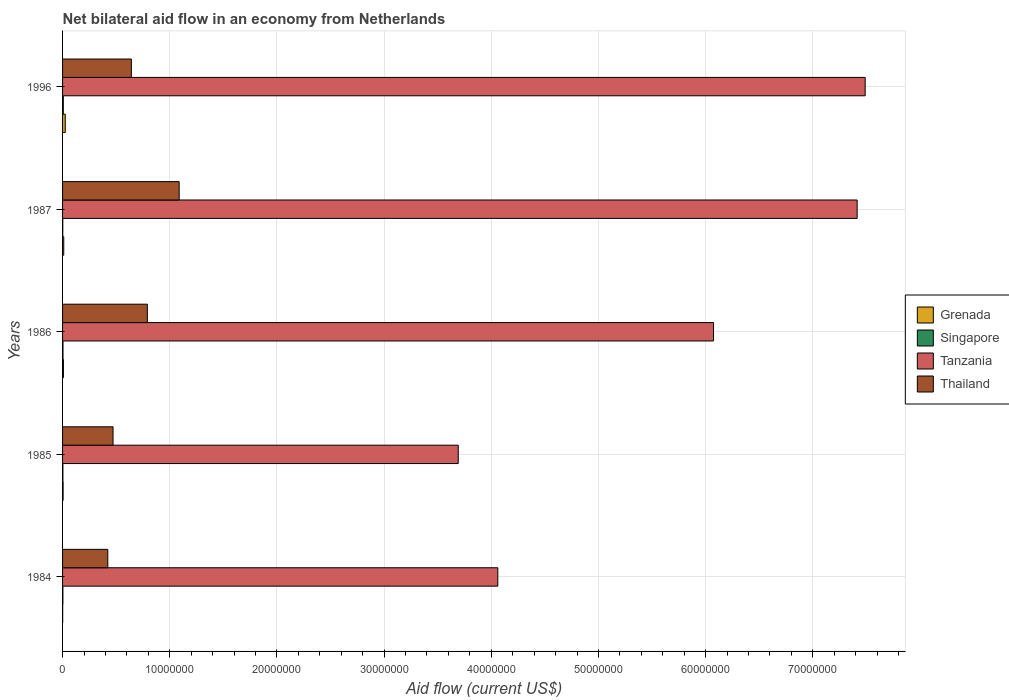How many bars are there on the 1st tick from the bottom?
Ensure brevity in your answer.  4. In how many cases, is the number of bars for a given year not equal to the number of legend labels?
Keep it short and to the point. 0. What is the net bilateral aid flow in Thailand in 1987?
Your answer should be very brief. 1.09e+07. Across all years, what is the maximum net bilateral aid flow in Singapore?
Your answer should be compact. 7.00e+04. Across all years, what is the minimum net bilateral aid flow in Thailand?
Ensure brevity in your answer.  4.22e+06. In which year was the net bilateral aid flow in Singapore maximum?
Your answer should be compact. 1996. What is the total net bilateral aid flow in Grenada in the graph?
Keep it short and to the point. 5.00e+05. What is the difference between the net bilateral aid flow in Tanzania in 1986 and that in 1996?
Give a very brief answer. -1.42e+07. What is the difference between the net bilateral aid flow in Singapore in 1996 and the net bilateral aid flow in Thailand in 1986?
Your response must be concise. -7.84e+06. What is the average net bilateral aid flow in Singapore per year?
Your answer should be compact. 3.80e+04. In the year 1984, what is the difference between the net bilateral aid flow in Singapore and net bilateral aid flow in Tanzania?
Give a very brief answer. -4.06e+07. What is the ratio of the net bilateral aid flow in Grenada in 1985 to that in 1987?
Offer a terse response. 0.45. What is the difference between the highest and the lowest net bilateral aid flow in Grenada?
Offer a terse response. 2.40e+05. Is the sum of the net bilateral aid flow in Singapore in 1984 and 1987 greater than the maximum net bilateral aid flow in Thailand across all years?
Your answer should be compact. No. Is it the case that in every year, the sum of the net bilateral aid flow in Tanzania and net bilateral aid flow in Thailand is greater than the sum of net bilateral aid flow in Singapore and net bilateral aid flow in Grenada?
Provide a succinct answer. No. What does the 3rd bar from the top in 1985 represents?
Your answer should be compact. Singapore. What does the 2nd bar from the bottom in 1984 represents?
Offer a terse response. Singapore. How many bars are there?
Keep it short and to the point. 20. Are all the bars in the graph horizontal?
Offer a very short reply. Yes. How many years are there in the graph?
Keep it short and to the point. 5. Are the values on the major ticks of X-axis written in scientific E-notation?
Give a very brief answer. No. How many legend labels are there?
Offer a very short reply. 4. How are the legend labels stacked?
Ensure brevity in your answer.  Vertical. What is the title of the graph?
Ensure brevity in your answer.  Net bilateral aid flow in an economy from Netherlands. Does "High income" appear as one of the legend labels in the graph?
Offer a terse response. No. What is the Aid flow (current US$) of Singapore in 1984?
Make the answer very short. 3.00e+04. What is the Aid flow (current US$) of Tanzania in 1984?
Ensure brevity in your answer.  4.06e+07. What is the Aid flow (current US$) in Thailand in 1984?
Your answer should be very brief. 4.22e+06. What is the Aid flow (current US$) of Grenada in 1985?
Ensure brevity in your answer.  5.00e+04. What is the Aid flow (current US$) of Singapore in 1985?
Ensure brevity in your answer.  3.00e+04. What is the Aid flow (current US$) in Tanzania in 1985?
Your response must be concise. 3.69e+07. What is the Aid flow (current US$) in Thailand in 1985?
Provide a short and direct response. 4.71e+06. What is the Aid flow (current US$) of Singapore in 1986?
Provide a short and direct response. 4.00e+04. What is the Aid flow (current US$) of Tanzania in 1986?
Make the answer very short. 6.07e+07. What is the Aid flow (current US$) of Thailand in 1986?
Provide a short and direct response. 7.91e+06. What is the Aid flow (current US$) in Tanzania in 1987?
Give a very brief answer. 7.41e+07. What is the Aid flow (current US$) of Thailand in 1987?
Provide a short and direct response. 1.09e+07. What is the Aid flow (current US$) in Grenada in 1996?
Your response must be concise. 2.50e+05. What is the Aid flow (current US$) of Tanzania in 1996?
Your answer should be very brief. 7.49e+07. What is the Aid flow (current US$) in Thailand in 1996?
Your response must be concise. 6.42e+06. Across all years, what is the maximum Aid flow (current US$) of Singapore?
Give a very brief answer. 7.00e+04. Across all years, what is the maximum Aid flow (current US$) of Tanzania?
Offer a terse response. 7.49e+07. Across all years, what is the maximum Aid flow (current US$) in Thailand?
Offer a very short reply. 1.09e+07. Across all years, what is the minimum Aid flow (current US$) in Tanzania?
Make the answer very short. 3.69e+07. Across all years, what is the minimum Aid flow (current US$) in Thailand?
Ensure brevity in your answer.  4.22e+06. What is the total Aid flow (current US$) of Singapore in the graph?
Provide a succinct answer. 1.90e+05. What is the total Aid flow (current US$) of Tanzania in the graph?
Provide a succinct answer. 2.87e+08. What is the total Aid flow (current US$) in Thailand in the graph?
Provide a short and direct response. 3.41e+07. What is the difference between the Aid flow (current US$) of Grenada in 1984 and that in 1985?
Keep it short and to the point. -4.00e+04. What is the difference between the Aid flow (current US$) in Singapore in 1984 and that in 1985?
Keep it short and to the point. 0. What is the difference between the Aid flow (current US$) of Tanzania in 1984 and that in 1985?
Offer a very short reply. 3.69e+06. What is the difference between the Aid flow (current US$) in Thailand in 1984 and that in 1985?
Provide a short and direct response. -4.90e+05. What is the difference between the Aid flow (current US$) in Grenada in 1984 and that in 1986?
Your answer should be very brief. -7.00e+04. What is the difference between the Aid flow (current US$) of Singapore in 1984 and that in 1986?
Your answer should be compact. -10000. What is the difference between the Aid flow (current US$) in Tanzania in 1984 and that in 1986?
Ensure brevity in your answer.  -2.01e+07. What is the difference between the Aid flow (current US$) of Thailand in 1984 and that in 1986?
Keep it short and to the point. -3.69e+06. What is the difference between the Aid flow (current US$) of Grenada in 1984 and that in 1987?
Provide a succinct answer. -1.00e+05. What is the difference between the Aid flow (current US$) of Tanzania in 1984 and that in 1987?
Keep it short and to the point. -3.35e+07. What is the difference between the Aid flow (current US$) in Thailand in 1984 and that in 1987?
Your response must be concise. -6.66e+06. What is the difference between the Aid flow (current US$) of Tanzania in 1984 and that in 1996?
Give a very brief answer. -3.43e+07. What is the difference between the Aid flow (current US$) of Thailand in 1984 and that in 1996?
Keep it short and to the point. -2.20e+06. What is the difference between the Aid flow (current US$) of Singapore in 1985 and that in 1986?
Offer a very short reply. -10000. What is the difference between the Aid flow (current US$) in Tanzania in 1985 and that in 1986?
Provide a short and direct response. -2.38e+07. What is the difference between the Aid flow (current US$) in Thailand in 1985 and that in 1986?
Provide a succinct answer. -3.20e+06. What is the difference between the Aid flow (current US$) of Grenada in 1985 and that in 1987?
Your answer should be compact. -6.00e+04. What is the difference between the Aid flow (current US$) in Singapore in 1985 and that in 1987?
Your response must be concise. 10000. What is the difference between the Aid flow (current US$) of Tanzania in 1985 and that in 1987?
Your response must be concise. -3.72e+07. What is the difference between the Aid flow (current US$) in Thailand in 1985 and that in 1987?
Your response must be concise. -6.17e+06. What is the difference between the Aid flow (current US$) in Grenada in 1985 and that in 1996?
Provide a succinct answer. -2.00e+05. What is the difference between the Aid flow (current US$) of Singapore in 1985 and that in 1996?
Provide a short and direct response. -4.00e+04. What is the difference between the Aid flow (current US$) in Tanzania in 1985 and that in 1996?
Ensure brevity in your answer.  -3.80e+07. What is the difference between the Aid flow (current US$) in Thailand in 1985 and that in 1996?
Offer a terse response. -1.71e+06. What is the difference between the Aid flow (current US$) of Grenada in 1986 and that in 1987?
Offer a very short reply. -3.00e+04. What is the difference between the Aid flow (current US$) in Tanzania in 1986 and that in 1987?
Your answer should be very brief. -1.34e+07. What is the difference between the Aid flow (current US$) in Thailand in 1986 and that in 1987?
Provide a succinct answer. -2.97e+06. What is the difference between the Aid flow (current US$) in Tanzania in 1986 and that in 1996?
Your response must be concise. -1.42e+07. What is the difference between the Aid flow (current US$) in Thailand in 1986 and that in 1996?
Give a very brief answer. 1.49e+06. What is the difference between the Aid flow (current US$) of Tanzania in 1987 and that in 1996?
Your answer should be very brief. -7.50e+05. What is the difference between the Aid flow (current US$) in Thailand in 1987 and that in 1996?
Give a very brief answer. 4.46e+06. What is the difference between the Aid flow (current US$) of Grenada in 1984 and the Aid flow (current US$) of Tanzania in 1985?
Give a very brief answer. -3.69e+07. What is the difference between the Aid flow (current US$) of Grenada in 1984 and the Aid flow (current US$) of Thailand in 1985?
Your answer should be compact. -4.70e+06. What is the difference between the Aid flow (current US$) in Singapore in 1984 and the Aid flow (current US$) in Tanzania in 1985?
Provide a short and direct response. -3.69e+07. What is the difference between the Aid flow (current US$) of Singapore in 1984 and the Aid flow (current US$) of Thailand in 1985?
Ensure brevity in your answer.  -4.68e+06. What is the difference between the Aid flow (current US$) of Tanzania in 1984 and the Aid flow (current US$) of Thailand in 1985?
Provide a short and direct response. 3.59e+07. What is the difference between the Aid flow (current US$) of Grenada in 1984 and the Aid flow (current US$) of Tanzania in 1986?
Provide a short and direct response. -6.07e+07. What is the difference between the Aid flow (current US$) in Grenada in 1984 and the Aid flow (current US$) in Thailand in 1986?
Give a very brief answer. -7.90e+06. What is the difference between the Aid flow (current US$) of Singapore in 1984 and the Aid flow (current US$) of Tanzania in 1986?
Provide a succinct answer. -6.07e+07. What is the difference between the Aid flow (current US$) in Singapore in 1984 and the Aid flow (current US$) in Thailand in 1986?
Give a very brief answer. -7.88e+06. What is the difference between the Aid flow (current US$) in Tanzania in 1984 and the Aid flow (current US$) in Thailand in 1986?
Ensure brevity in your answer.  3.27e+07. What is the difference between the Aid flow (current US$) in Grenada in 1984 and the Aid flow (current US$) in Singapore in 1987?
Give a very brief answer. -10000. What is the difference between the Aid flow (current US$) of Grenada in 1984 and the Aid flow (current US$) of Tanzania in 1987?
Offer a terse response. -7.41e+07. What is the difference between the Aid flow (current US$) in Grenada in 1984 and the Aid flow (current US$) in Thailand in 1987?
Give a very brief answer. -1.09e+07. What is the difference between the Aid flow (current US$) of Singapore in 1984 and the Aid flow (current US$) of Tanzania in 1987?
Offer a very short reply. -7.41e+07. What is the difference between the Aid flow (current US$) in Singapore in 1984 and the Aid flow (current US$) in Thailand in 1987?
Your answer should be very brief. -1.08e+07. What is the difference between the Aid flow (current US$) in Tanzania in 1984 and the Aid flow (current US$) in Thailand in 1987?
Offer a very short reply. 2.97e+07. What is the difference between the Aid flow (current US$) of Grenada in 1984 and the Aid flow (current US$) of Tanzania in 1996?
Your response must be concise. -7.49e+07. What is the difference between the Aid flow (current US$) of Grenada in 1984 and the Aid flow (current US$) of Thailand in 1996?
Make the answer very short. -6.41e+06. What is the difference between the Aid flow (current US$) of Singapore in 1984 and the Aid flow (current US$) of Tanzania in 1996?
Ensure brevity in your answer.  -7.49e+07. What is the difference between the Aid flow (current US$) in Singapore in 1984 and the Aid flow (current US$) in Thailand in 1996?
Give a very brief answer. -6.39e+06. What is the difference between the Aid flow (current US$) of Tanzania in 1984 and the Aid flow (current US$) of Thailand in 1996?
Your answer should be compact. 3.42e+07. What is the difference between the Aid flow (current US$) of Grenada in 1985 and the Aid flow (current US$) of Singapore in 1986?
Offer a very short reply. 10000. What is the difference between the Aid flow (current US$) in Grenada in 1985 and the Aid flow (current US$) in Tanzania in 1986?
Your answer should be compact. -6.07e+07. What is the difference between the Aid flow (current US$) of Grenada in 1985 and the Aid flow (current US$) of Thailand in 1986?
Offer a terse response. -7.86e+06. What is the difference between the Aid flow (current US$) in Singapore in 1985 and the Aid flow (current US$) in Tanzania in 1986?
Your response must be concise. -6.07e+07. What is the difference between the Aid flow (current US$) of Singapore in 1985 and the Aid flow (current US$) of Thailand in 1986?
Offer a very short reply. -7.88e+06. What is the difference between the Aid flow (current US$) in Tanzania in 1985 and the Aid flow (current US$) in Thailand in 1986?
Your answer should be very brief. 2.90e+07. What is the difference between the Aid flow (current US$) of Grenada in 1985 and the Aid flow (current US$) of Tanzania in 1987?
Your answer should be compact. -7.41e+07. What is the difference between the Aid flow (current US$) in Grenada in 1985 and the Aid flow (current US$) in Thailand in 1987?
Offer a terse response. -1.08e+07. What is the difference between the Aid flow (current US$) in Singapore in 1985 and the Aid flow (current US$) in Tanzania in 1987?
Make the answer very short. -7.41e+07. What is the difference between the Aid flow (current US$) of Singapore in 1985 and the Aid flow (current US$) of Thailand in 1987?
Provide a short and direct response. -1.08e+07. What is the difference between the Aid flow (current US$) in Tanzania in 1985 and the Aid flow (current US$) in Thailand in 1987?
Offer a terse response. 2.60e+07. What is the difference between the Aid flow (current US$) of Grenada in 1985 and the Aid flow (current US$) of Singapore in 1996?
Give a very brief answer. -2.00e+04. What is the difference between the Aid flow (current US$) of Grenada in 1985 and the Aid flow (current US$) of Tanzania in 1996?
Make the answer very short. -7.48e+07. What is the difference between the Aid flow (current US$) of Grenada in 1985 and the Aid flow (current US$) of Thailand in 1996?
Provide a short and direct response. -6.37e+06. What is the difference between the Aid flow (current US$) of Singapore in 1985 and the Aid flow (current US$) of Tanzania in 1996?
Provide a short and direct response. -7.49e+07. What is the difference between the Aid flow (current US$) of Singapore in 1985 and the Aid flow (current US$) of Thailand in 1996?
Keep it short and to the point. -6.39e+06. What is the difference between the Aid flow (current US$) in Tanzania in 1985 and the Aid flow (current US$) in Thailand in 1996?
Your answer should be very brief. 3.05e+07. What is the difference between the Aid flow (current US$) in Grenada in 1986 and the Aid flow (current US$) in Singapore in 1987?
Provide a succinct answer. 6.00e+04. What is the difference between the Aid flow (current US$) of Grenada in 1986 and the Aid flow (current US$) of Tanzania in 1987?
Keep it short and to the point. -7.41e+07. What is the difference between the Aid flow (current US$) in Grenada in 1986 and the Aid flow (current US$) in Thailand in 1987?
Keep it short and to the point. -1.08e+07. What is the difference between the Aid flow (current US$) of Singapore in 1986 and the Aid flow (current US$) of Tanzania in 1987?
Your answer should be very brief. -7.41e+07. What is the difference between the Aid flow (current US$) of Singapore in 1986 and the Aid flow (current US$) of Thailand in 1987?
Your answer should be very brief. -1.08e+07. What is the difference between the Aid flow (current US$) of Tanzania in 1986 and the Aid flow (current US$) of Thailand in 1987?
Keep it short and to the point. 4.99e+07. What is the difference between the Aid flow (current US$) in Grenada in 1986 and the Aid flow (current US$) in Tanzania in 1996?
Give a very brief answer. -7.48e+07. What is the difference between the Aid flow (current US$) of Grenada in 1986 and the Aid flow (current US$) of Thailand in 1996?
Ensure brevity in your answer.  -6.34e+06. What is the difference between the Aid flow (current US$) in Singapore in 1986 and the Aid flow (current US$) in Tanzania in 1996?
Provide a succinct answer. -7.48e+07. What is the difference between the Aid flow (current US$) in Singapore in 1986 and the Aid flow (current US$) in Thailand in 1996?
Provide a short and direct response. -6.38e+06. What is the difference between the Aid flow (current US$) of Tanzania in 1986 and the Aid flow (current US$) of Thailand in 1996?
Offer a terse response. 5.43e+07. What is the difference between the Aid flow (current US$) of Grenada in 1987 and the Aid flow (current US$) of Singapore in 1996?
Keep it short and to the point. 4.00e+04. What is the difference between the Aid flow (current US$) in Grenada in 1987 and the Aid flow (current US$) in Tanzania in 1996?
Offer a terse response. -7.48e+07. What is the difference between the Aid flow (current US$) of Grenada in 1987 and the Aid flow (current US$) of Thailand in 1996?
Your response must be concise. -6.31e+06. What is the difference between the Aid flow (current US$) of Singapore in 1987 and the Aid flow (current US$) of Tanzania in 1996?
Provide a succinct answer. -7.49e+07. What is the difference between the Aid flow (current US$) of Singapore in 1987 and the Aid flow (current US$) of Thailand in 1996?
Your answer should be compact. -6.40e+06. What is the difference between the Aid flow (current US$) in Tanzania in 1987 and the Aid flow (current US$) in Thailand in 1996?
Keep it short and to the point. 6.77e+07. What is the average Aid flow (current US$) of Grenada per year?
Your answer should be compact. 1.00e+05. What is the average Aid flow (current US$) of Singapore per year?
Your answer should be very brief. 3.80e+04. What is the average Aid flow (current US$) in Tanzania per year?
Offer a very short reply. 5.75e+07. What is the average Aid flow (current US$) of Thailand per year?
Keep it short and to the point. 6.83e+06. In the year 1984, what is the difference between the Aid flow (current US$) of Grenada and Aid flow (current US$) of Singapore?
Make the answer very short. -2.00e+04. In the year 1984, what is the difference between the Aid flow (current US$) in Grenada and Aid flow (current US$) in Tanzania?
Your answer should be very brief. -4.06e+07. In the year 1984, what is the difference between the Aid flow (current US$) of Grenada and Aid flow (current US$) of Thailand?
Provide a succinct answer. -4.21e+06. In the year 1984, what is the difference between the Aid flow (current US$) of Singapore and Aid flow (current US$) of Tanzania?
Your response must be concise. -4.06e+07. In the year 1984, what is the difference between the Aid flow (current US$) of Singapore and Aid flow (current US$) of Thailand?
Keep it short and to the point. -4.19e+06. In the year 1984, what is the difference between the Aid flow (current US$) in Tanzania and Aid flow (current US$) in Thailand?
Make the answer very short. 3.64e+07. In the year 1985, what is the difference between the Aid flow (current US$) in Grenada and Aid flow (current US$) in Singapore?
Make the answer very short. 2.00e+04. In the year 1985, what is the difference between the Aid flow (current US$) of Grenada and Aid flow (current US$) of Tanzania?
Ensure brevity in your answer.  -3.69e+07. In the year 1985, what is the difference between the Aid flow (current US$) of Grenada and Aid flow (current US$) of Thailand?
Ensure brevity in your answer.  -4.66e+06. In the year 1985, what is the difference between the Aid flow (current US$) of Singapore and Aid flow (current US$) of Tanzania?
Your answer should be very brief. -3.69e+07. In the year 1985, what is the difference between the Aid flow (current US$) of Singapore and Aid flow (current US$) of Thailand?
Give a very brief answer. -4.68e+06. In the year 1985, what is the difference between the Aid flow (current US$) in Tanzania and Aid flow (current US$) in Thailand?
Offer a terse response. 3.22e+07. In the year 1986, what is the difference between the Aid flow (current US$) of Grenada and Aid flow (current US$) of Singapore?
Your answer should be compact. 4.00e+04. In the year 1986, what is the difference between the Aid flow (current US$) of Grenada and Aid flow (current US$) of Tanzania?
Make the answer very short. -6.07e+07. In the year 1986, what is the difference between the Aid flow (current US$) in Grenada and Aid flow (current US$) in Thailand?
Offer a very short reply. -7.83e+06. In the year 1986, what is the difference between the Aid flow (current US$) in Singapore and Aid flow (current US$) in Tanzania?
Provide a short and direct response. -6.07e+07. In the year 1986, what is the difference between the Aid flow (current US$) in Singapore and Aid flow (current US$) in Thailand?
Make the answer very short. -7.87e+06. In the year 1986, what is the difference between the Aid flow (current US$) in Tanzania and Aid flow (current US$) in Thailand?
Your answer should be very brief. 5.28e+07. In the year 1987, what is the difference between the Aid flow (current US$) in Grenada and Aid flow (current US$) in Tanzania?
Offer a terse response. -7.40e+07. In the year 1987, what is the difference between the Aid flow (current US$) in Grenada and Aid flow (current US$) in Thailand?
Provide a succinct answer. -1.08e+07. In the year 1987, what is the difference between the Aid flow (current US$) in Singapore and Aid flow (current US$) in Tanzania?
Your answer should be compact. -7.41e+07. In the year 1987, what is the difference between the Aid flow (current US$) in Singapore and Aid flow (current US$) in Thailand?
Ensure brevity in your answer.  -1.09e+07. In the year 1987, what is the difference between the Aid flow (current US$) in Tanzania and Aid flow (current US$) in Thailand?
Offer a terse response. 6.33e+07. In the year 1996, what is the difference between the Aid flow (current US$) in Grenada and Aid flow (current US$) in Tanzania?
Keep it short and to the point. -7.46e+07. In the year 1996, what is the difference between the Aid flow (current US$) of Grenada and Aid flow (current US$) of Thailand?
Offer a terse response. -6.17e+06. In the year 1996, what is the difference between the Aid flow (current US$) of Singapore and Aid flow (current US$) of Tanzania?
Your response must be concise. -7.48e+07. In the year 1996, what is the difference between the Aid flow (current US$) of Singapore and Aid flow (current US$) of Thailand?
Ensure brevity in your answer.  -6.35e+06. In the year 1996, what is the difference between the Aid flow (current US$) in Tanzania and Aid flow (current US$) in Thailand?
Offer a very short reply. 6.85e+07. What is the ratio of the Aid flow (current US$) in Grenada in 1984 to that in 1985?
Your response must be concise. 0.2. What is the ratio of the Aid flow (current US$) of Singapore in 1984 to that in 1985?
Provide a succinct answer. 1. What is the ratio of the Aid flow (current US$) in Tanzania in 1984 to that in 1985?
Provide a short and direct response. 1.1. What is the ratio of the Aid flow (current US$) in Thailand in 1984 to that in 1985?
Offer a terse response. 0.9. What is the ratio of the Aid flow (current US$) of Tanzania in 1984 to that in 1986?
Make the answer very short. 0.67. What is the ratio of the Aid flow (current US$) of Thailand in 1984 to that in 1986?
Ensure brevity in your answer.  0.53. What is the ratio of the Aid flow (current US$) in Grenada in 1984 to that in 1987?
Ensure brevity in your answer.  0.09. What is the ratio of the Aid flow (current US$) of Singapore in 1984 to that in 1987?
Give a very brief answer. 1.5. What is the ratio of the Aid flow (current US$) in Tanzania in 1984 to that in 1987?
Provide a succinct answer. 0.55. What is the ratio of the Aid flow (current US$) in Thailand in 1984 to that in 1987?
Keep it short and to the point. 0.39. What is the ratio of the Aid flow (current US$) of Singapore in 1984 to that in 1996?
Offer a terse response. 0.43. What is the ratio of the Aid flow (current US$) of Tanzania in 1984 to that in 1996?
Ensure brevity in your answer.  0.54. What is the ratio of the Aid flow (current US$) in Thailand in 1984 to that in 1996?
Your answer should be compact. 0.66. What is the ratio of the Aid flow (current US$) of Singapore in 1985 to that in 1986?
Provide a succinct answer. 0.75. What is the ratio of the Aid flow (current US$) in Tanzania in 1985 to that in 1986?
Provide a short and direct response. 0.61. What is the ratio of the Aid flow (current US$) of Thailand in 1985 to that in 1986?
Provide a short and direct response. 0.6. What is the ratio of the Aid flow (current US$) in Grenada in 1985 to that in 1987?
Offer a terse response. 0.45. What is the ratio of the Aid flow (current US$) of Tanzania in 1985 to that in 1987?
Keep it short and to the point. 0.5. What is the ratio of the Aid flow (current US$) of Thailand in 1985 to that in 1987?
Offer a very short reply. 0.43. What is the ratio of the Aid flow (current US$) of Grenada in 1985 to that in 1996?
Offer a terse response. 0.2. What is the ratio of the Aid flow (current US$) in Singapore in 1985 to that in 1996?
Ensure brevity in your answer.  0.43. What is the ratio of the Aid flow (current US$) in Tanzania in 1985 to that in 1996?
Ensure brevity in your answer.  0.49. What is the ratio of the Aid flow (current US$) of Thailand in 1985 to that in 1996?
Ensure brevity in your answer.  0.73. What is the ratio of the Aid flow (current US$) of Grenada in 1986 to that in 1987?
Ensure brevity in your answer.  0.73. What is the ratio of the Aid flow (current US$) in Tanzania in 1986 to that in 1987?
Your answer should be very brief. 0.82. What is the ratio of the Aid flow (current US$) in Thailand in 1986 to that in 1987?
Provide a short and direct response. 0.73. What is the ratio of the Aid flow (current US$) in Grenada in 1986 to that in 1996?
Make the answer very short. 0.32. What is the ratio of the Aid flow (current US$) in Singapore in 1986 to that in 1996?
Give a very brief answer. 0.57. What is the ratio of the Aid flow (current US$) of Tanzania in 1986 to that in 1996?
Keep it short and to the point. 0.81. What is the ratio of the Aid flow (current US$) in Thailand in 1986 to that in 1996?
Provide a short and direct response. 1.23. What is the ratio of the Aid flow (current US$) of Grenada in 1987 to that in 1996?
Make the answer very short. 0.44. What is the ratio of the Aid flow (current US$) of Singapore in 1987 to that in 1996?
Ensure brevity in your answer.  0.29. What is the ratio of the Aid flow (current US$) in Tanzania in 1987 to that in 1996?
Your answer should be compact. 0.99. What is the ratio of the Aid flow (current US$) of Thailand in 1987 to that in 1996?
Your response must be concise. 1.69. What is the difference between the highest and the second highest Aid flow (current US$) in Grenada?
Your response must be concise. 1.40e+05. What is the difference between the highest and the second highest Aid flow (current US$) in Tanzania?
Offer a very short reply. 7.50e+05. What is the difference between the highest and the second highest Aid flow (current US$) in Thailand?
Ensure brevity in your answer.  2.97e+06. What is the difference between the highest and the lowest Aid flow (current US$) of Singapore?
Give a very brief answer. 5.00e+04. What is the difference between the highest and the lowest Aid flow (current US$) in Tanzania?
Your response must be concise. 3.80e+07. What is the difference between the highest and the lowest Aid flow (current US$) of Thailand?
Provide a succinct answer. 6.66e+06. 